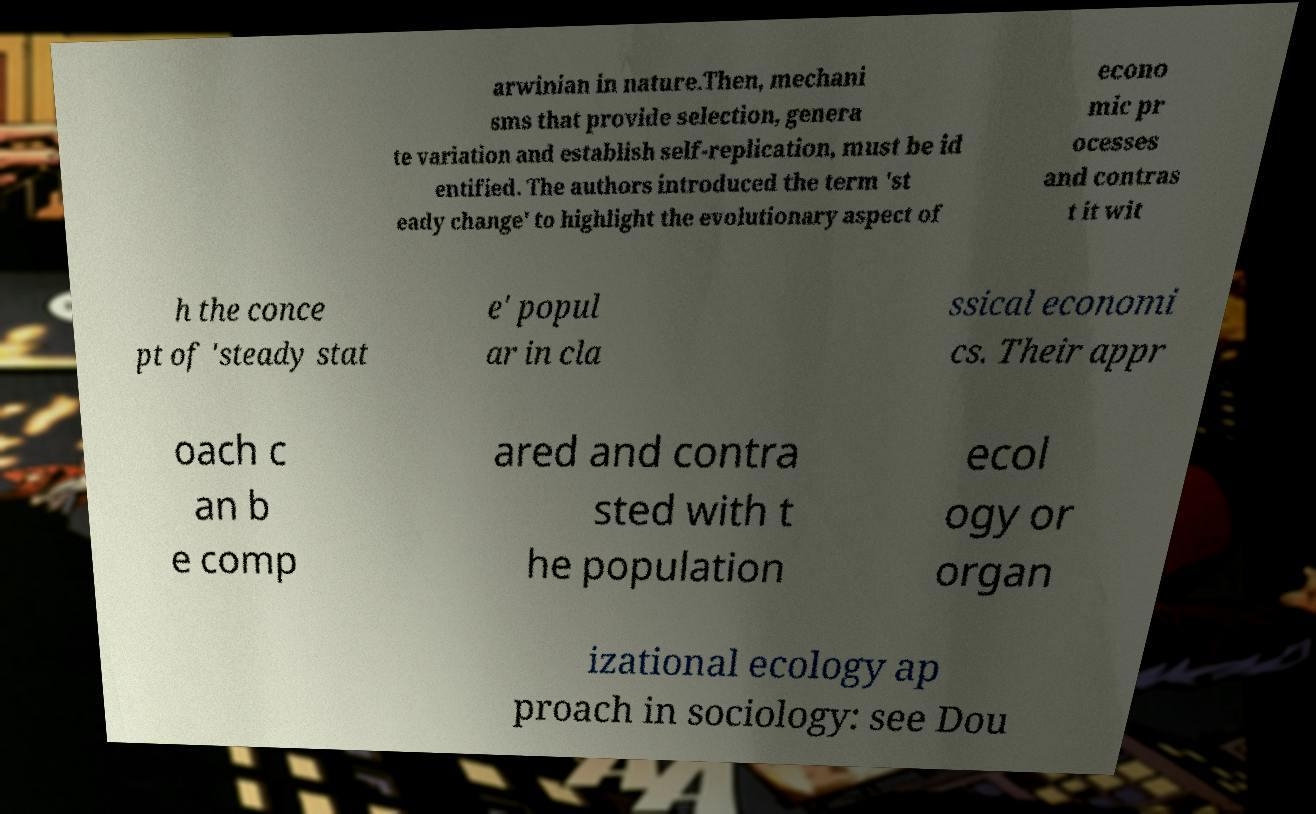I need the written content from this picture converted into text. Can you do that? arwinian in nature.Then, mechani sms that provide selection, genera te variation and establish self-replication, must be id entified. The authors introduced the term 'st eady change' to highlight the evolutionary aspect of econo mic pr ocesses and contras t it wit h the conce pt of 'steady stat e' popul ar in cla ssical economi cs. Their appr oach c an b e comp ared and contra sted with t he population ecol ogy or organ izational ecology ap proach in sociology: see Dou 